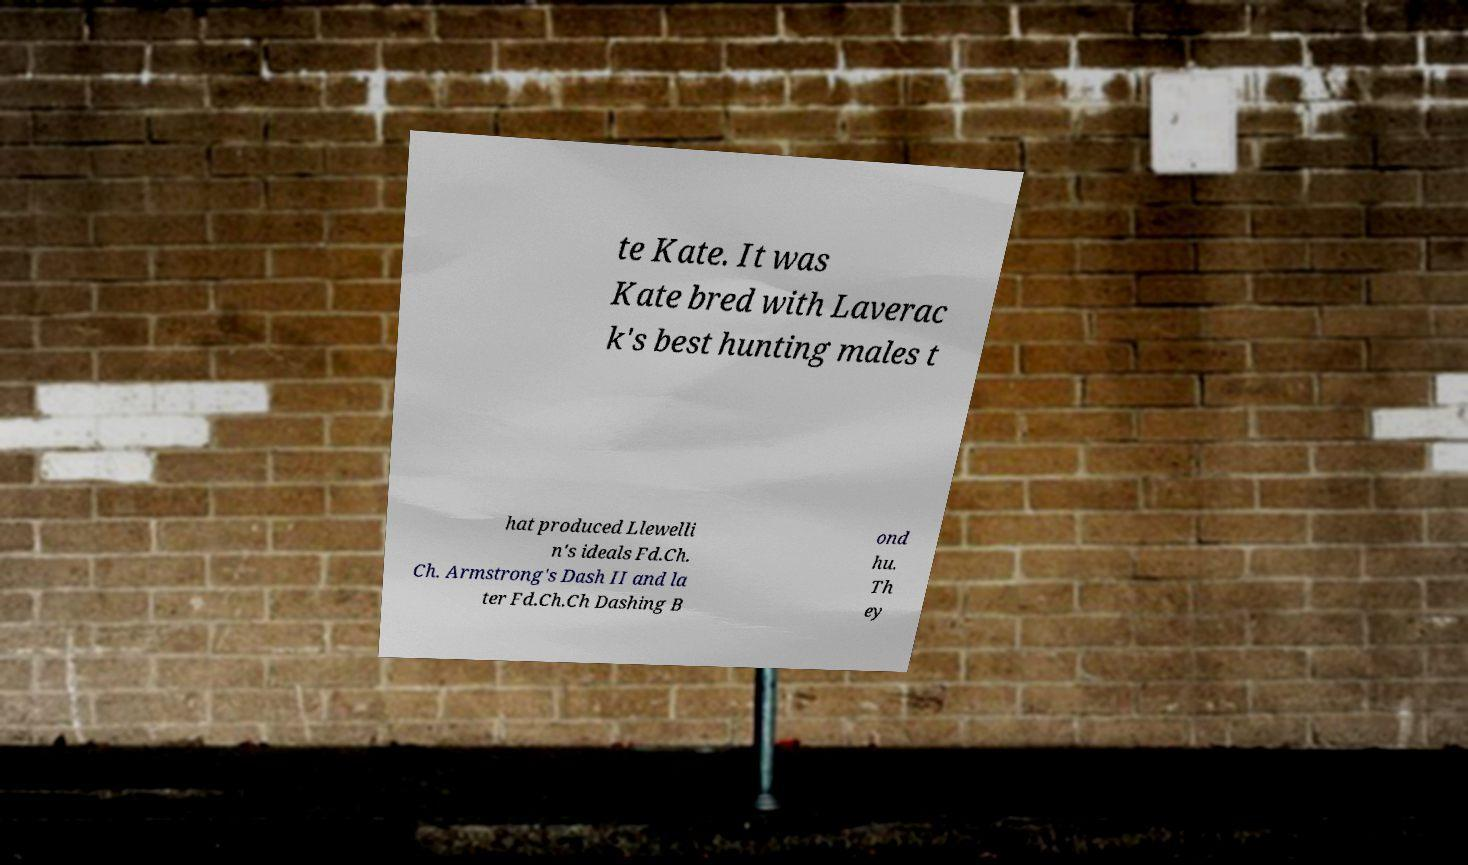Could you assist in decoding the text presented in this image and type it out clearly? te Kate. It was Kate bred with Laverac k's best hunting males t hat produced Llewelli n's ideals Fd.Ch. Ch. Armstrong's Dash II and la ter Fd.Ch.Ch Dashing B ond hu. Th ey 